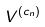Convert formula to latex. <formula><loc_0><loc_0><loc_500><loc_500>V ^ { ( c _ { n } ) }</formula> 